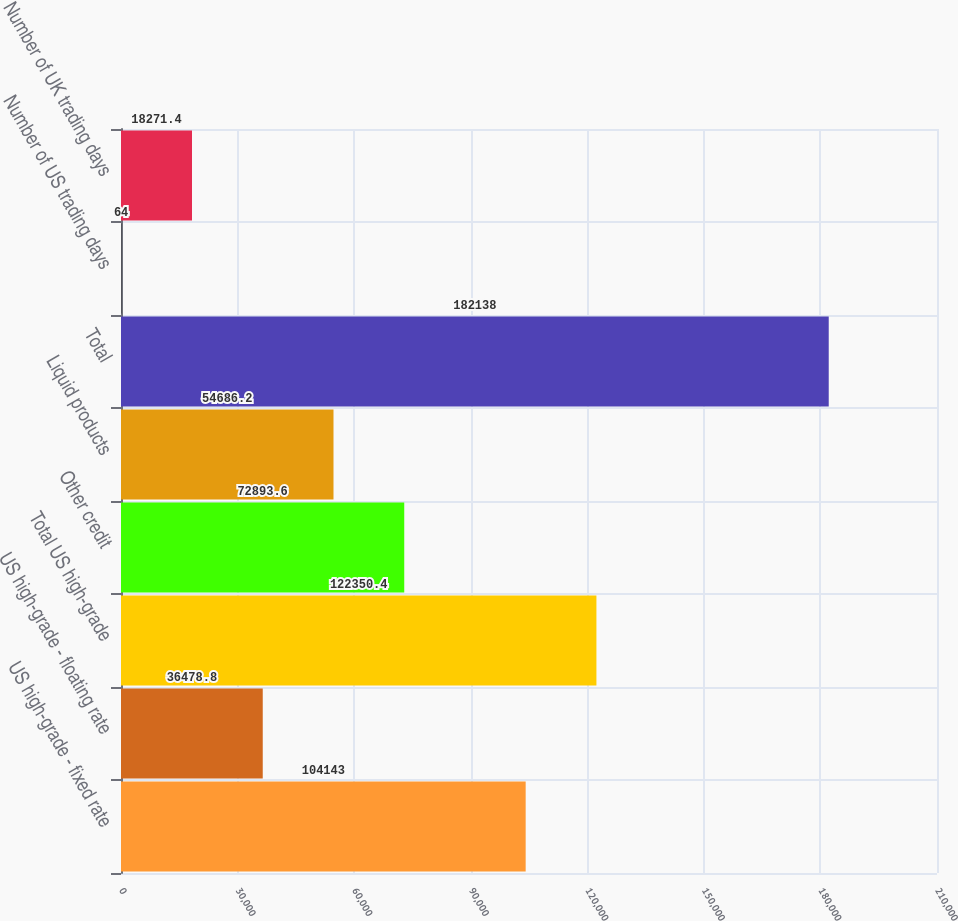Convert chart. <chart><loc_0><loc_0><loc_500><loc_500><bar_chart><fcel>US high-grade - fixed rate<fcel>US high-grade - floating rate<fcel>Total US high-grade<fcel>Other credit<fcel>Liquid products<fcel>Total<fcel>Number of US trading days<fcel>Number of UK trading days<nl><fcel>104143<fcel>36478.8<fcel>122350<fcel>72893.6<fcel>54686.2<fcel>182138<fcel>64<fcel>18271.4<nl></chart> 